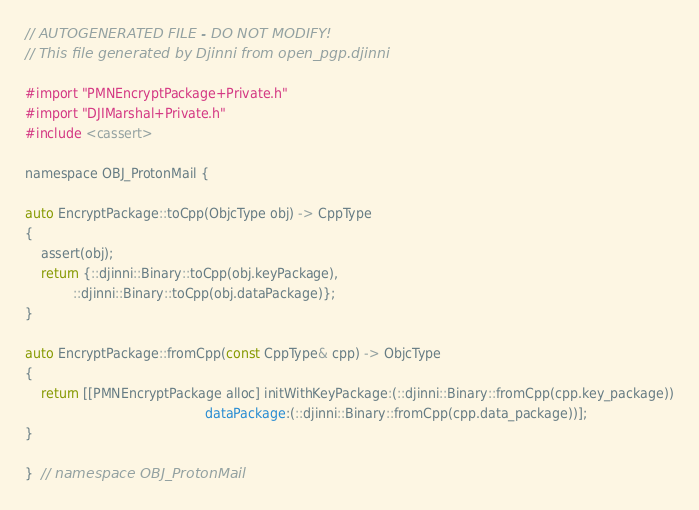Convert code to text. <code><loc_0><loc_0><loc_500><loc_500><_ObjectiveC_>// AUTOGENERATED FILE - DO NOT MODIFY!
// This file generated by Djinni from open_pgp.djinni

#import "PMNEncryptPackage+Private.h"
#import "DJIMarshal+Private.h"
#include <cassert>

namespace OBJ_ProtonMail {

auto EncryptPackage::toCpp(ObjcType obj) -> CppType
{
    assert(obj);
    return {::djinni::Binary::toCpp(obj.keyPackage),
            ::djinni::Binary::toCpp(obj.dataPackage)};
}

auto EncryptPackage::fromCpp(const CppType& cpp) -> ObjcType
{
    return [[PMNEncryptPackage alloc] initWithKeyPackage:(::djinni::Binary::fromCpp(cpp.key_package))
                                             dataPackage:(::djinni::Binary::fromCpp(cpp.data_package))];
}

}  // namespace OBJ_ProtonMail
</code> 